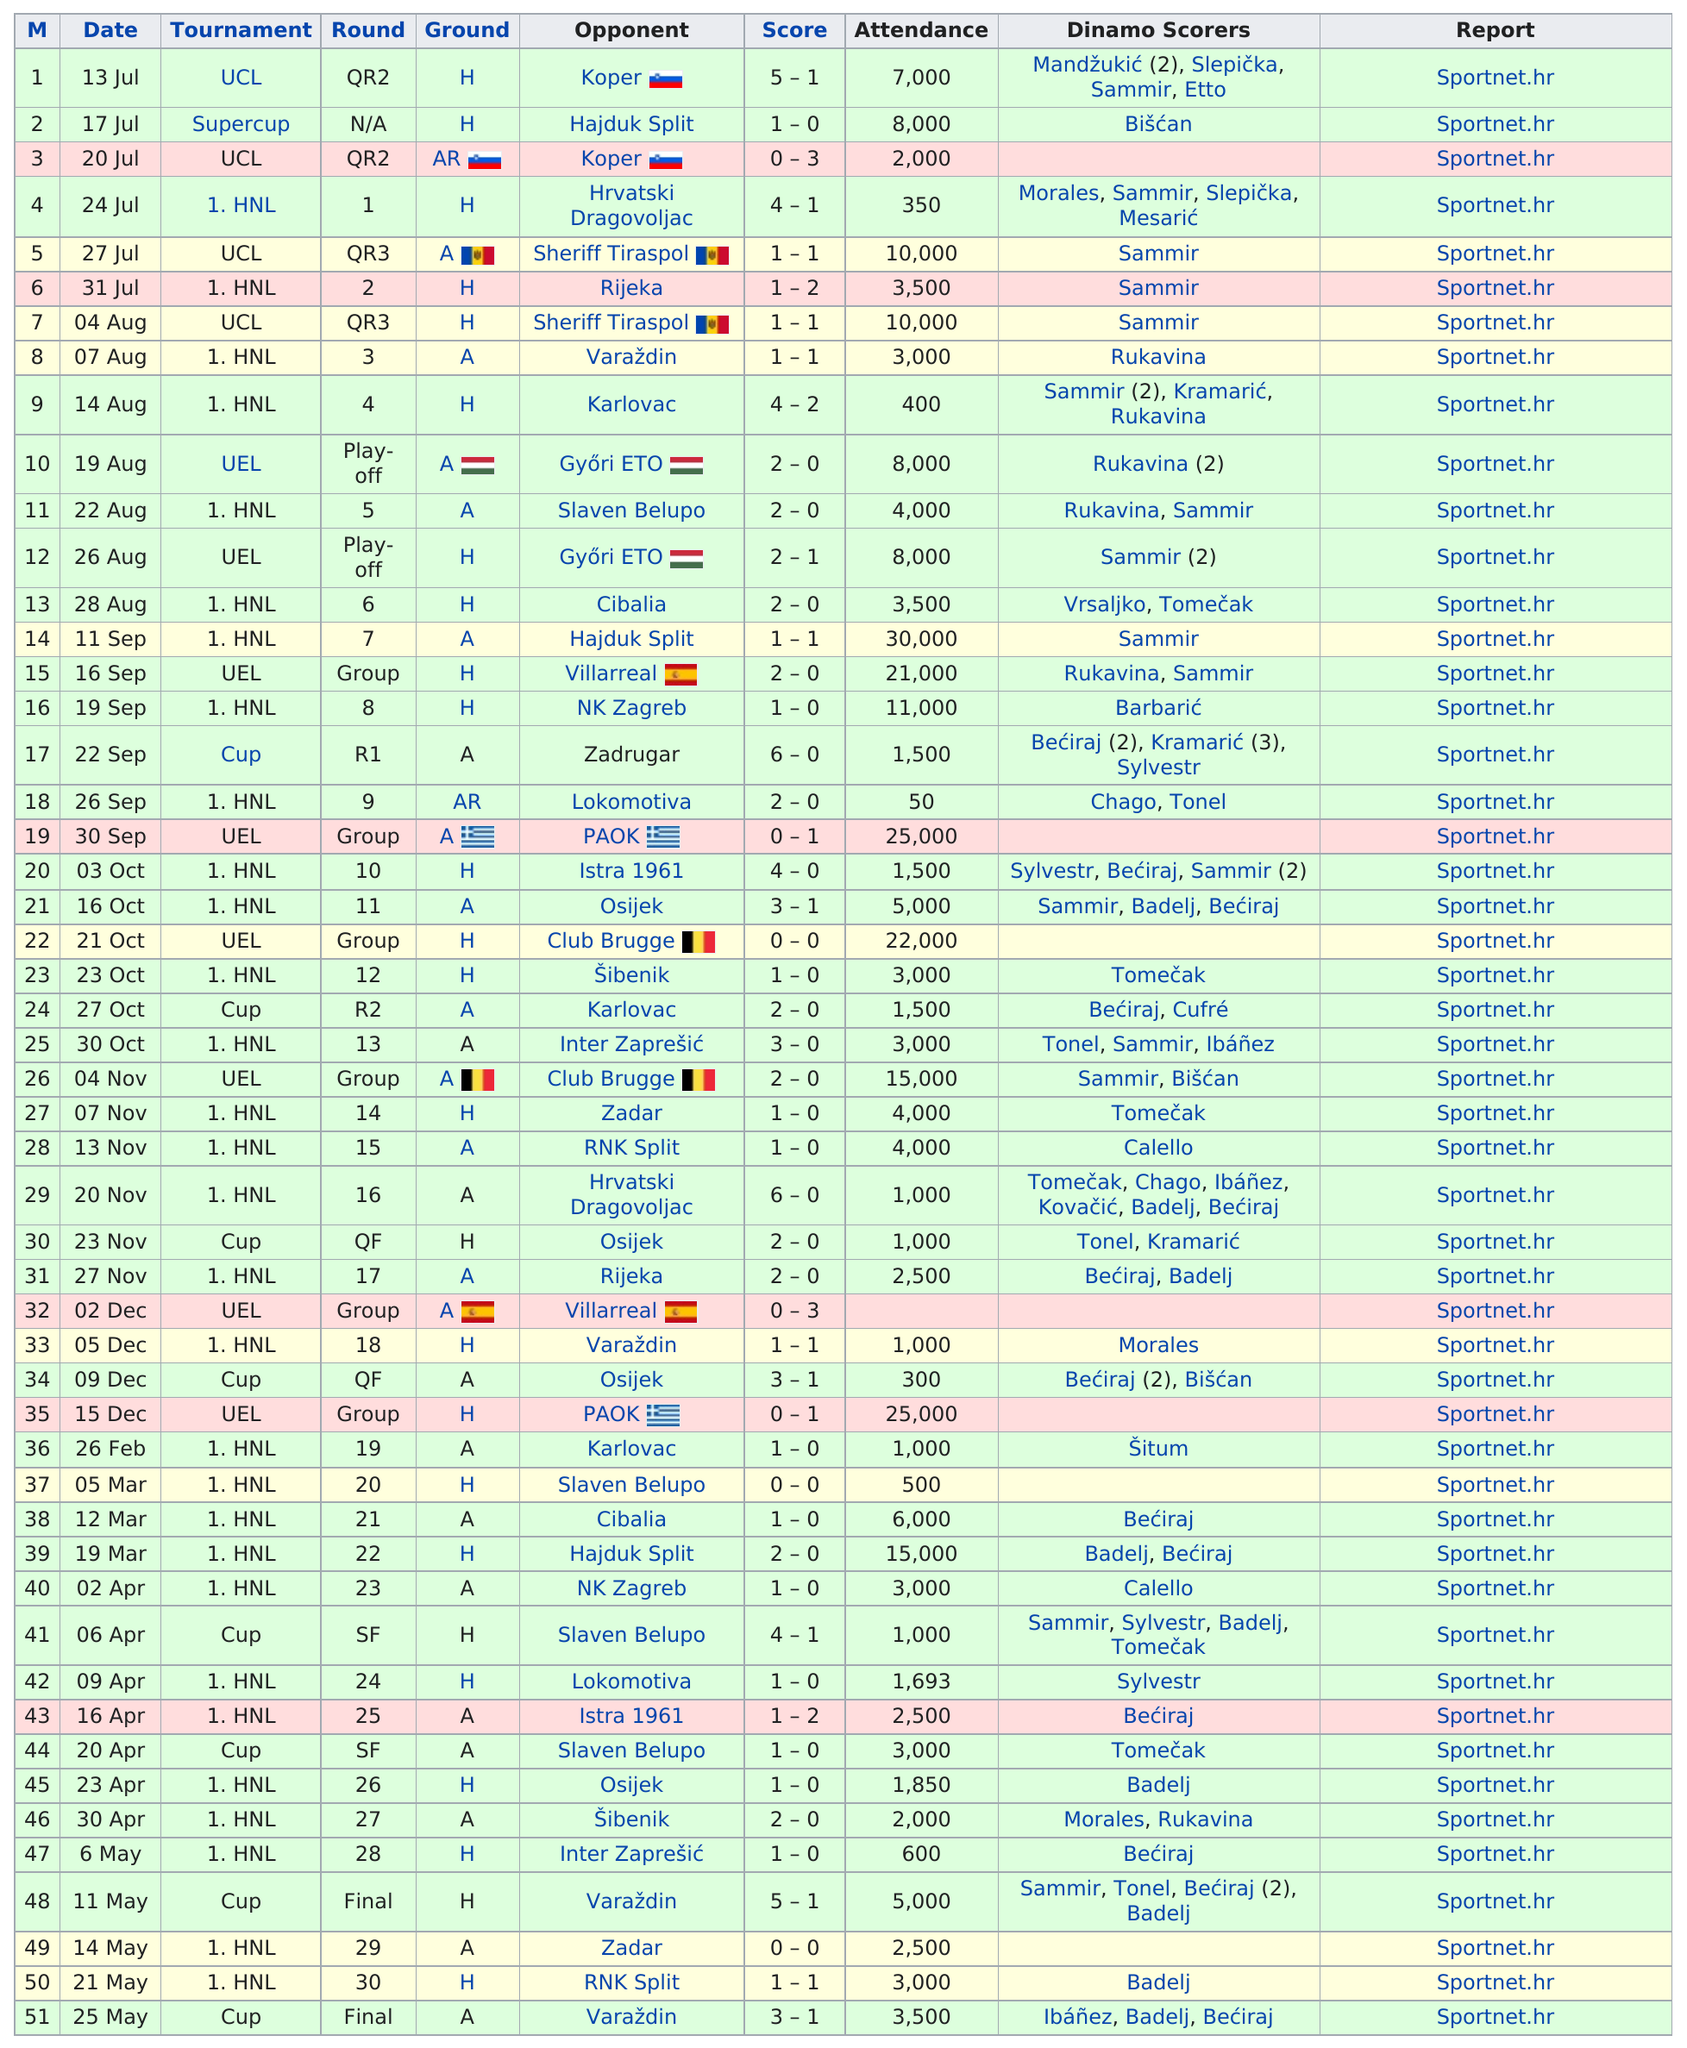List a handful of essential elements in this visual. In total, 13 games were attended by at least 8,000 people. On July 13, the number of points scored in the first game was 4, while the number of points scored in the 18th game on September 26 was different. To date, this team has amassed a total of 94 points, a testament to their offensive prowess this season. The total attendance in the month of February was 1,000. In August, a total of 7 games were played. 